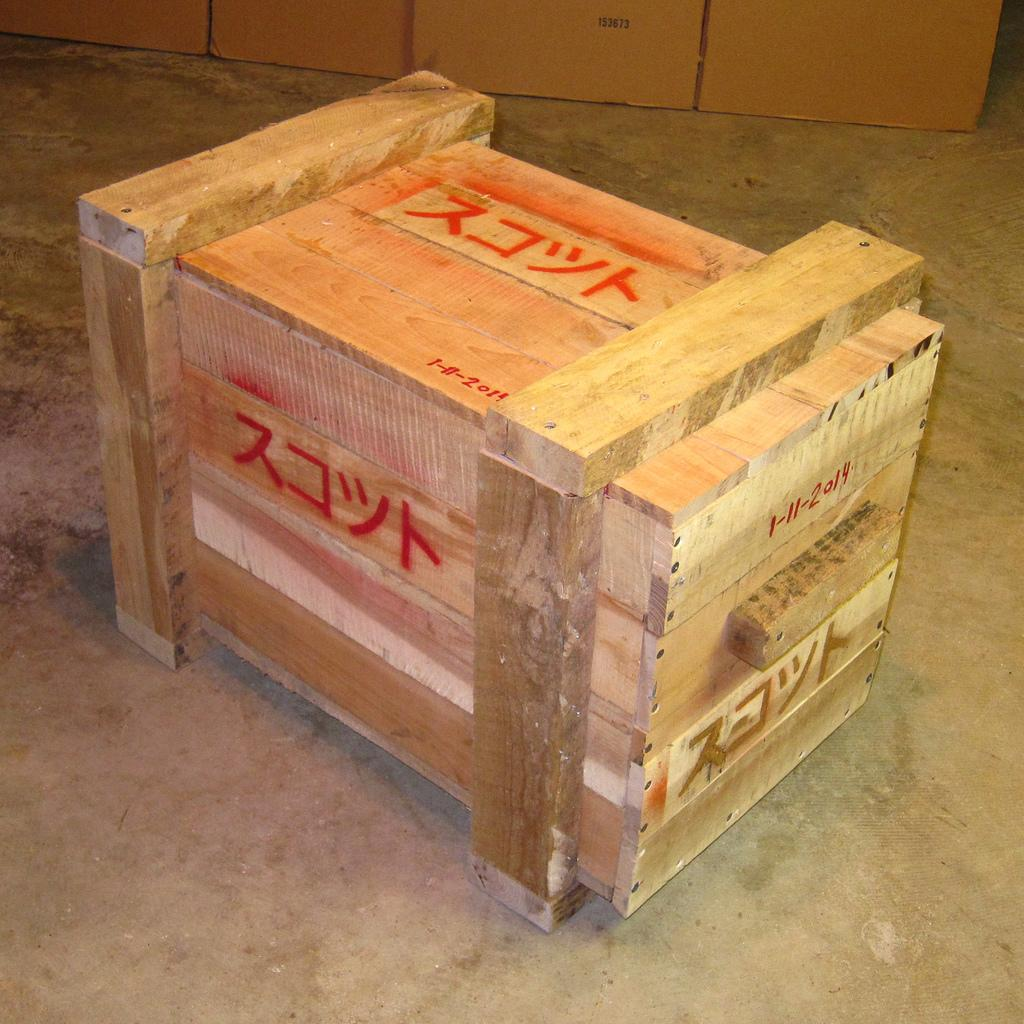What is located on the ground in the foreground of the image? There is a crate on the ground in the foreground of the image. What can be seen in the background of the image? There are cardboard boxes in the background of the image. How does the crate react to the earthquake in the image? There is no earthquake present in the image, so the crate's reaction cannot be determined. 